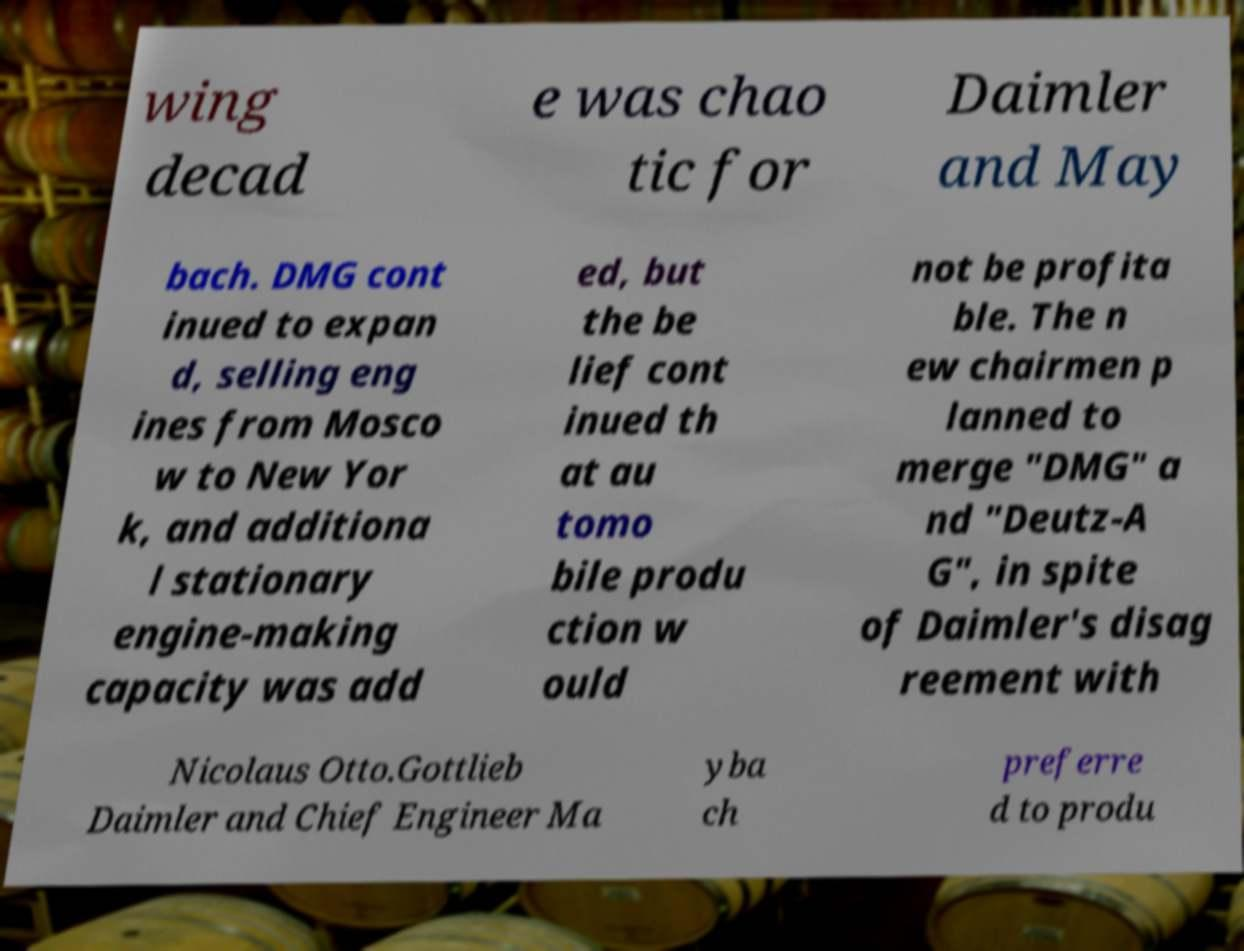Can you read and provide the text displayed in the image?This photo seems to have some interesting text. Can you extract and type it out for me? wing decad e was chao tic for Daimler and May bach. DMG cont inued to expan d, selling eng ines from Mosco w to New Yor k, and additiona l stationary engine-making capacity was add ed, but the be lief cont inued th at au tomo bile produ ction w ould not be profita ble. The n ew chairmen p lanned to merge "DMG" a nd "Deutz-A G", in spite of Daimler's disag reement with Nicolaus Otto.Gottlieb Daimler and Chief Engineer Ma yba ch preferre d to produ 